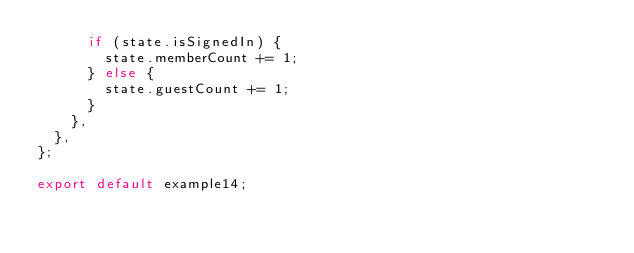<code> <loc_0><loc_0><loc_500><loc_500><_JavaScript_>      if (state.isSignedIn) {
        state.memberCount += 1;
      } else {
        state.guestCount += 1;
      }
    },
  },
};

export default example14;
</code> 